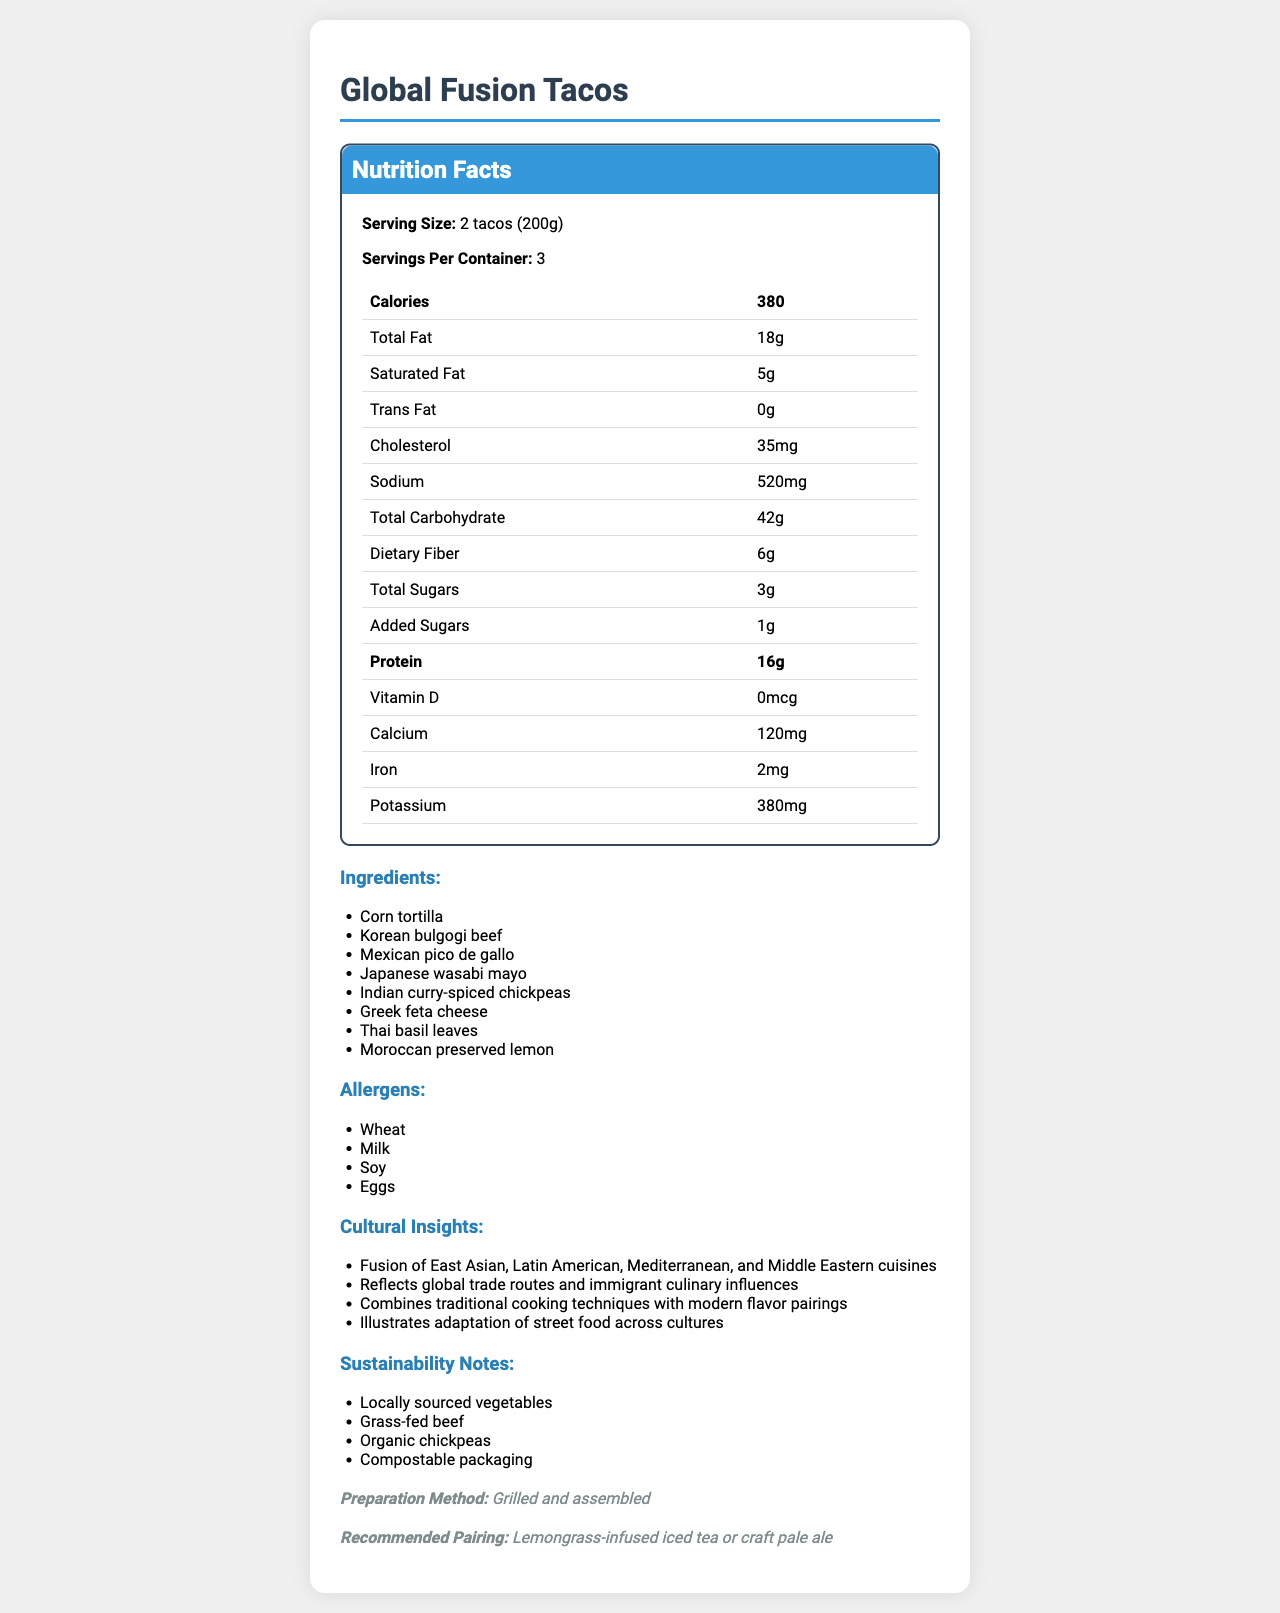what is the serving size for Global Fusion Tacos? The document explicitly states that the serving size is "2 tacos (200g)."
Answer: 2 tacos (200g) how many servings are in one container? The document mentions that there are 3 servings per container.
Answer: 3 how many grams of dietary fiber are in one serving? According to the nutrition facts, each serving contains 6 grams of dietary fiber.
Answer: 6g list any four ingredients used in Global Fusion Tacos. Four of the listed ingredients are “Corn tortilla,” “Korean bulgogi beef,” “Mexican pico de gallo,” and “Japanese wasabi mayo.”
Answer: Corn tortilla, Korean bulgogi beef, Mexican pico de gallo, Japanese wasabi mayo which cultural cuisines are combined in this fusion dish? The cultural insights section mentions the fusion of East Asian, Latin American, Mediterranean, and Middle Eastern cuisines.
Answer: East Asian, Latin American, Mediterranean, Middle Eastern what is the total fat content in one serving? The nutrition facts indicate that one serving contains 18 grams of total fat.
Answer: 18g how many milligrams of sodium are there in one serving? The nutrition facts table lists the sodium content as 520 milligrams per serving.
Answer: 520mg which item is not listed as an allergen in Global Fusion Tacos? A. Wheat B. Milk C. Peanuts D. Soy The allergens listed are Wheat, Milk, Soy, and Eggs, but not Peanuts.
Answer: C. Peanuts what is the total number of calories per serving? A. 350 B. 360 C. 370 D. 380 The document states that each serving of the product contains 380 calories.
Answer: D. 380 is the preparation method for Global Fusion Tacos roasting? The preparation method listed in the document is "Grilled and assembled," not roasting.
Answer: No describe the main idea of the document. The document gives detailed nutrition facts, the cultural and sustainability background, ingredients list, allergens, preparation method, and recommended pairings for a multicultural fusion dish named "Global Fusion Tacos."
Answer: The document provides nutritional information, ingredient details, and cultural/sustainability insights for "Global Fusion Tacos," a dish that combines elements from multiple cultural cuisines. how many grams of protein are in a serving? The nutrition facts section states that there are 16 grams of protein in one serving.
Answer: 16g what is the exact amount of added sugars per serving? According to the nutrition facts, there is 1 gram of added sugars per serving.
Answer: 1g which ingredient provides a Greek culinary influence? The ingredient list includes "Greek feta cheese," indicating its Greek culinary influence.
Answer: Greek feta cheese what is the recommended drink pairing for Global Fusion Tacos? The document suggests pairing the dish with either Lemongrass-infused iced tea or craft pale ale.
Answer: Lemongrass-infused iced tea or craft pale ale does the document provide information on vitamin C content? The document lists various nutrients including Vitamin D, Calcium, Iron, and Potassium, but it does not mention Vitamin C content.
Answer: No 